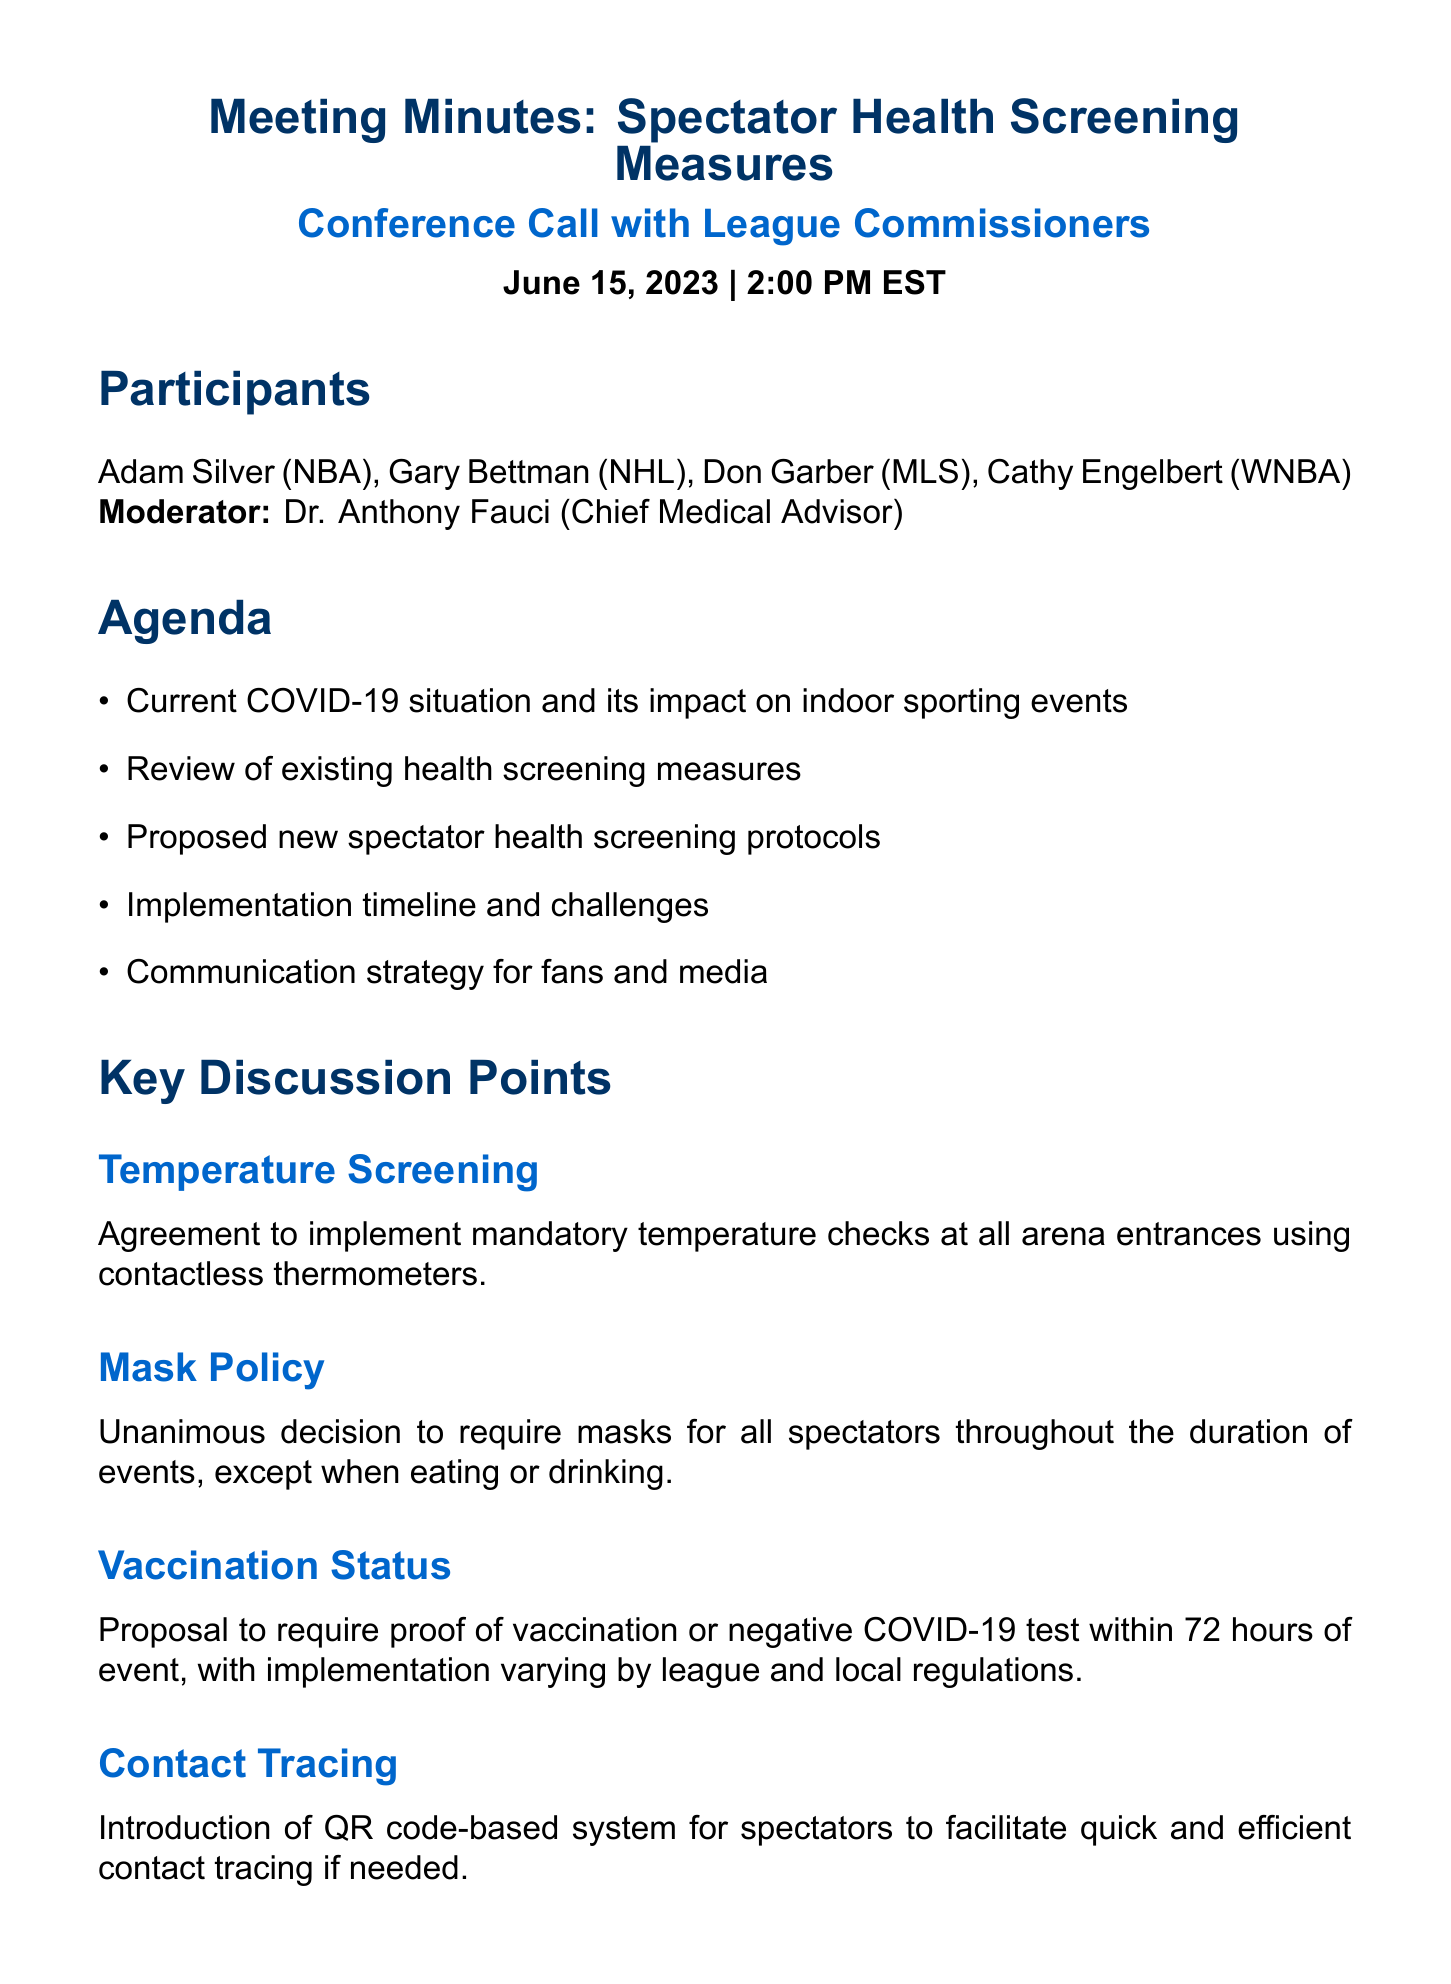What is the date of the conference call? The date of the conference call is stated in the meeting details section of the document.
Answer: June 15, 2023 Who is the moderator of the meeting? The moderator is mentioned at the beginning of the document where participants are listed.
Answer: Dr. Anthony Fauci What is one key discussion point regarding masks? The document lists decision points specifically about masks during the key discussion section.
Answer: Require masks for all spectators What is the deadline for leagues to draft implementation plans? The deadline for implementation plans is noted in the action items of the document.
Answer: July 1, 2023 What is a proposed method for contact tracing? The document provides details on contact tracing as a key discussion point.
Answer: QR code-based system What challenge involves regulations? The challenges discussed section mentions issues related to regulations.
Answer: Varying local and state regulations Which league commissioner is from the NHL? The participants section lists the league commissioners along with their respective leagues.
Answer: Gary Bettman When is the follow-up meeting scheduled? The follow-up meeting date is included in the action items.
Answer: July 15, 2023 